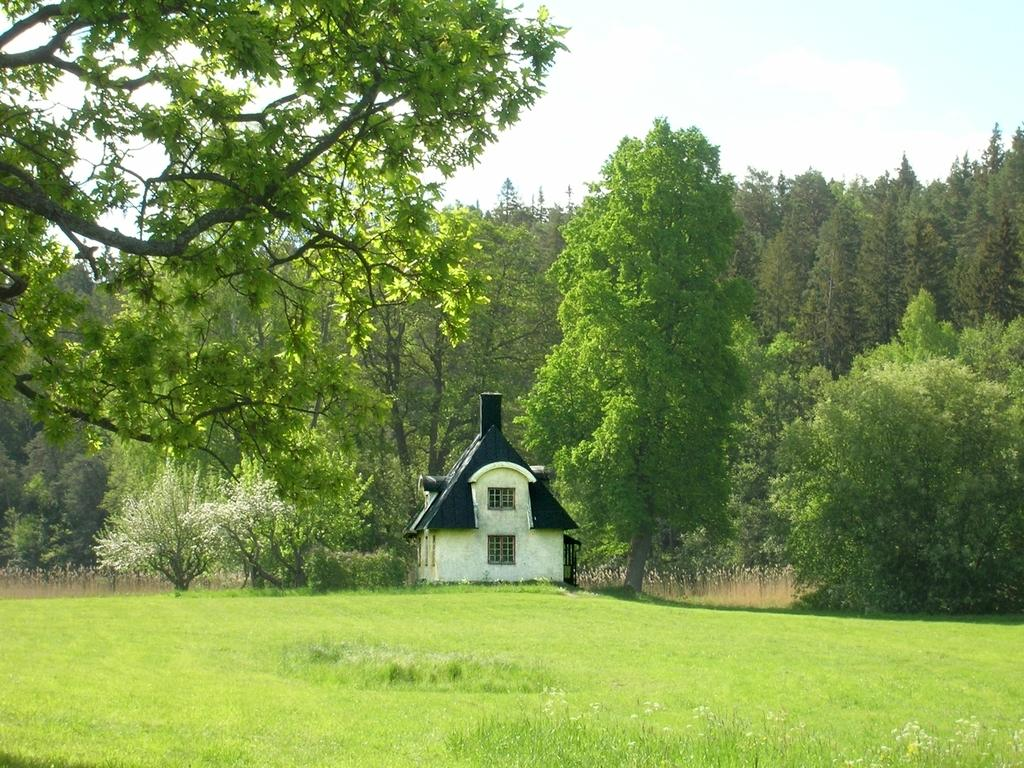What type of structure is visible in the image? There is a house in the image. What features can be seen on the house? The house has a roof and windows. What type of vegetation is present in the image? There is grass, plants, and a group of trees in the image. What is visible in the background of the image? The sky is visible in the image, and it appears to be cloudy. Where is the library located in the image? There is no library present in the image. Can you see a ring on any of the trees in the image? There are no rings visible on the trees in the image. 